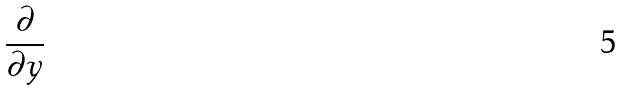<formula> <loc_0><loc_0><loc_500><loc_500>\frac { \partial } { \partial y }</formula> 